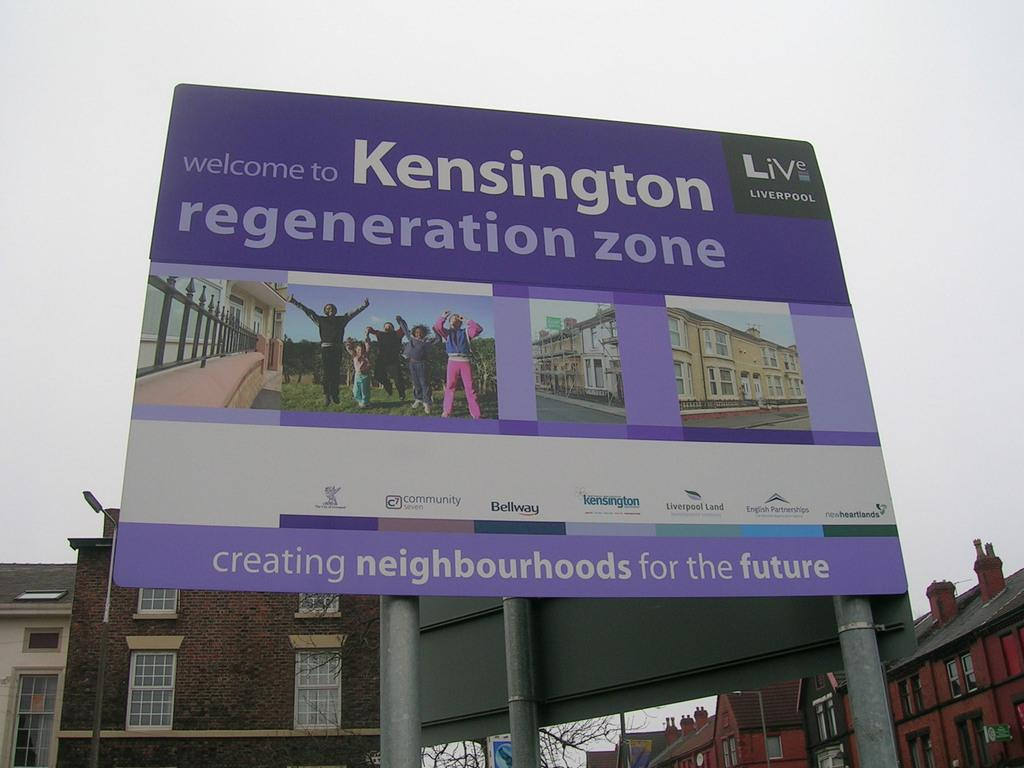<image>
Summarize the visual content of the image. A large purple welcome sign to the kensington regeneration zone. 